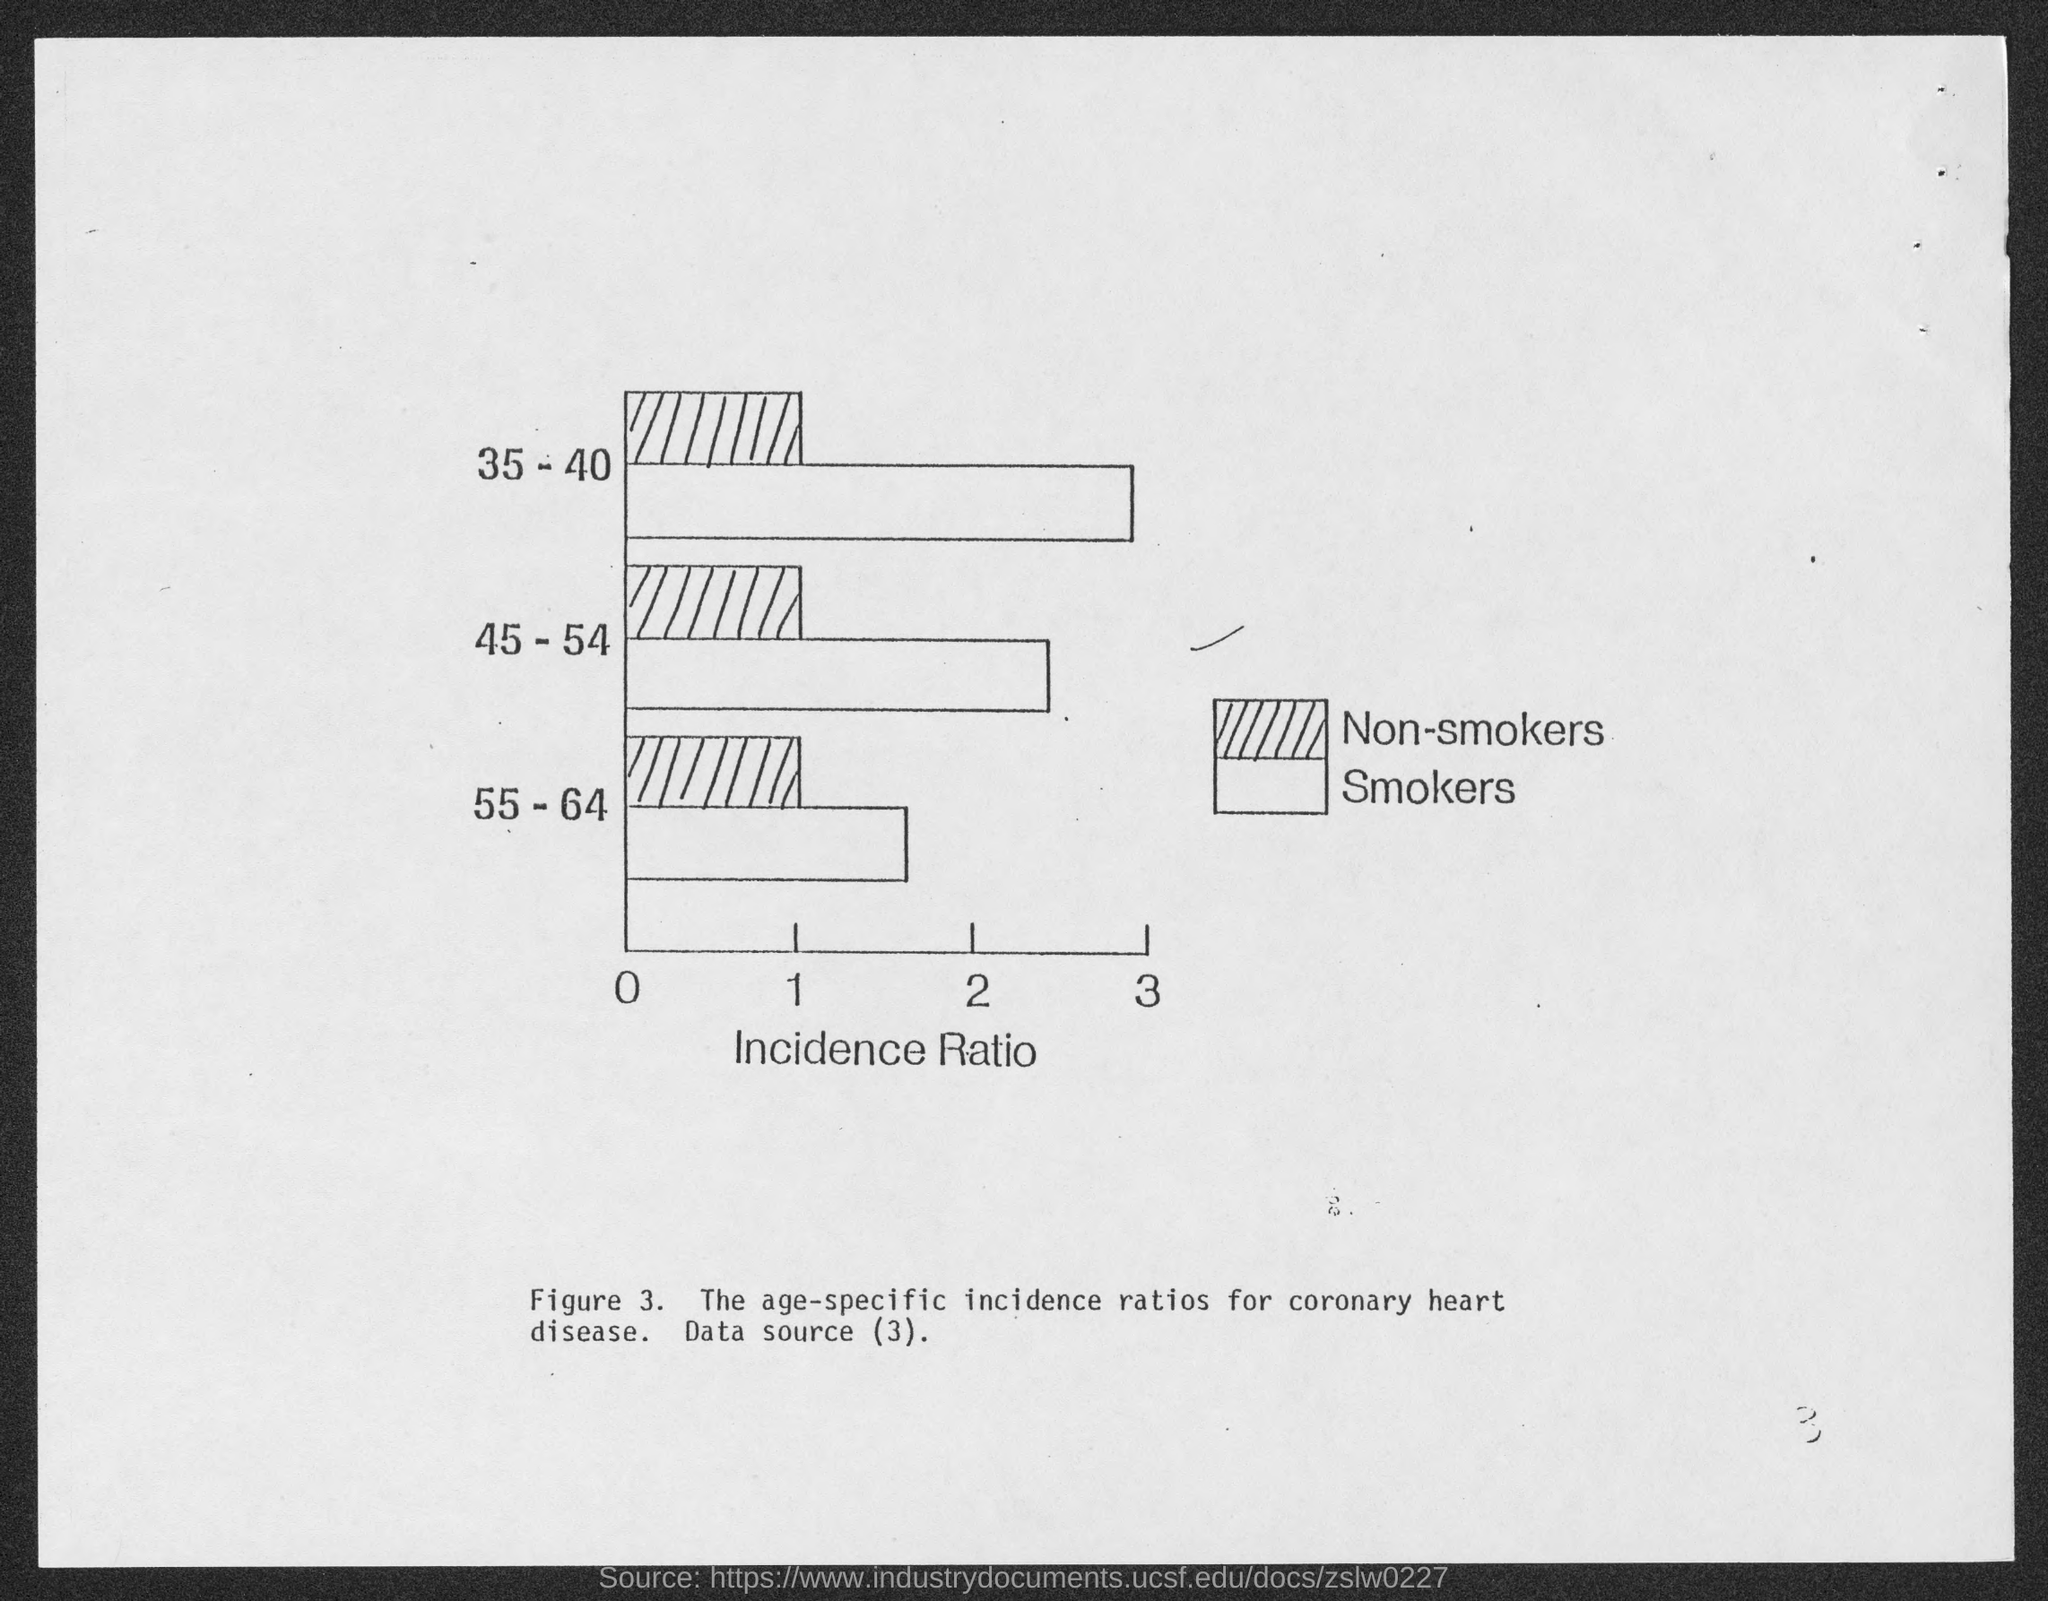What is written on x- axis of the figure?
Your response must be concise. Incidence ratio. 